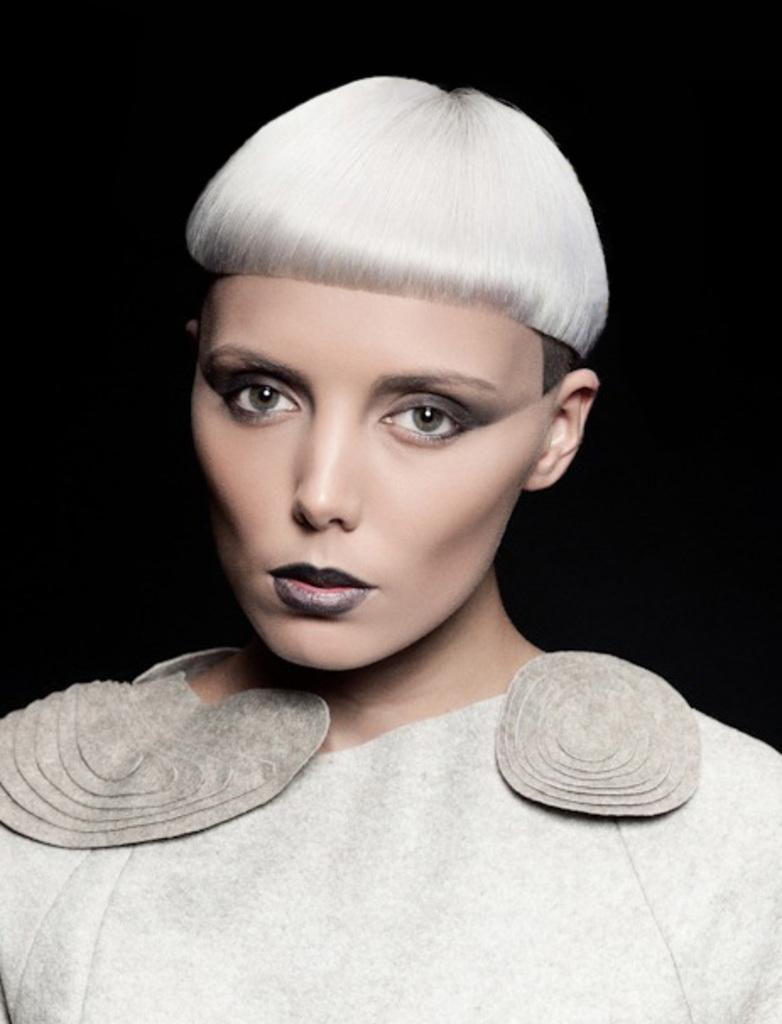Who is the main subject in the image? There is a woman in the image. What is the woman wearing? The woman is wearing a white and light brown color dress. Can you describe the background of the image? The background of the image is dark. What is the color of the woman's hair? The woman's hair is white in color. What type of robin can be seen perched on the woman's shoulder in the image? There is no robin present in the image; it only features the woman and the dark background. 